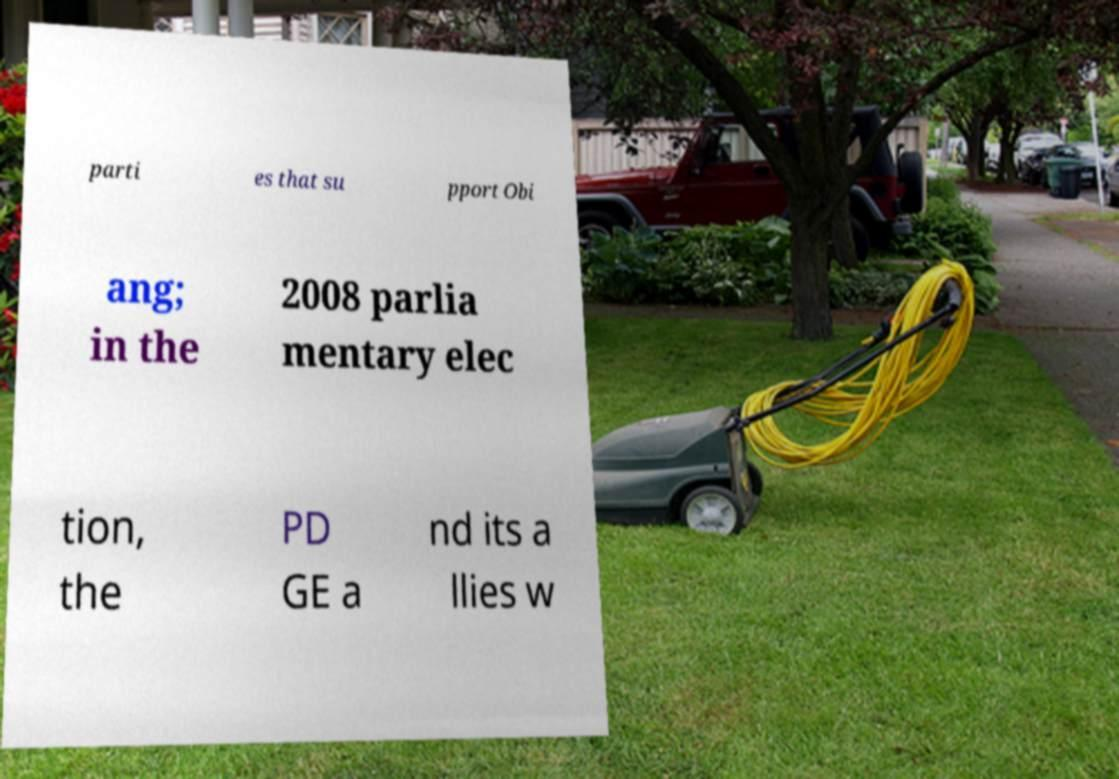Please identify and transcribe the text found in this image. parti es that su pport Obi ang; in the 2008 parlia mentary elec tion, the PD GE a nd its a llies w 